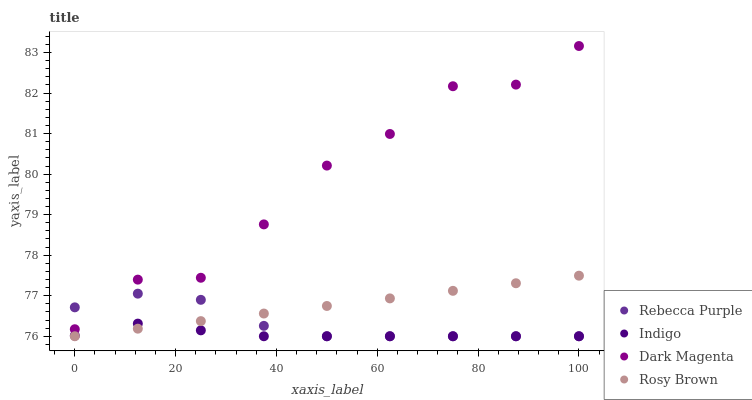Does Indigo have the minimum area under the curve?
Answer yes or no. Yes. Does Dark Magenta have the maximum area under the curve?
Answer yes or no. Yes. Does Rebecca Purple have the minimum area under the curve?
Answer yes or no. No. Does Rebecca Purple have the maximum area under the curve?
Answer yes or no. No. Is Rosy Brown the smoothest?
Answer yes or no. Yes. Is Dark Magenta the roughest?
Answer yes or no. Yes. Is Indigo the smoothest?
Answer yes or no. No. Is Indigo the roughest?
Answer yes or no. No. Does Rosy Brown have the lowest value?
Answer yes or no. Yes. Does Dark Magenta have the lowest value?
Answer yes or no. No. Does Dark Magenta have the highest value?
Answer yes or no. Yes. Does Rebecca Purple have the highest value?
Answer yes or no. No. Is Rosy Brown less than Dark Magenta?
Answer yes or no. Yes. Is Dark Magenta greater than Rosy Brown?
Answer yes or no. Yes. Does Rosy Brown intersect Rebecca Purple?
Answer yes or no. Yes. Is Rosy Brown less than Rebecca Purple?
Answer yes or no. No. Is Rosy Brown greater than Rebecca Purple?
Answer yes or no. No. Does Rosy Brown intersect Dark Magenta?
Answer yes or no. No. 